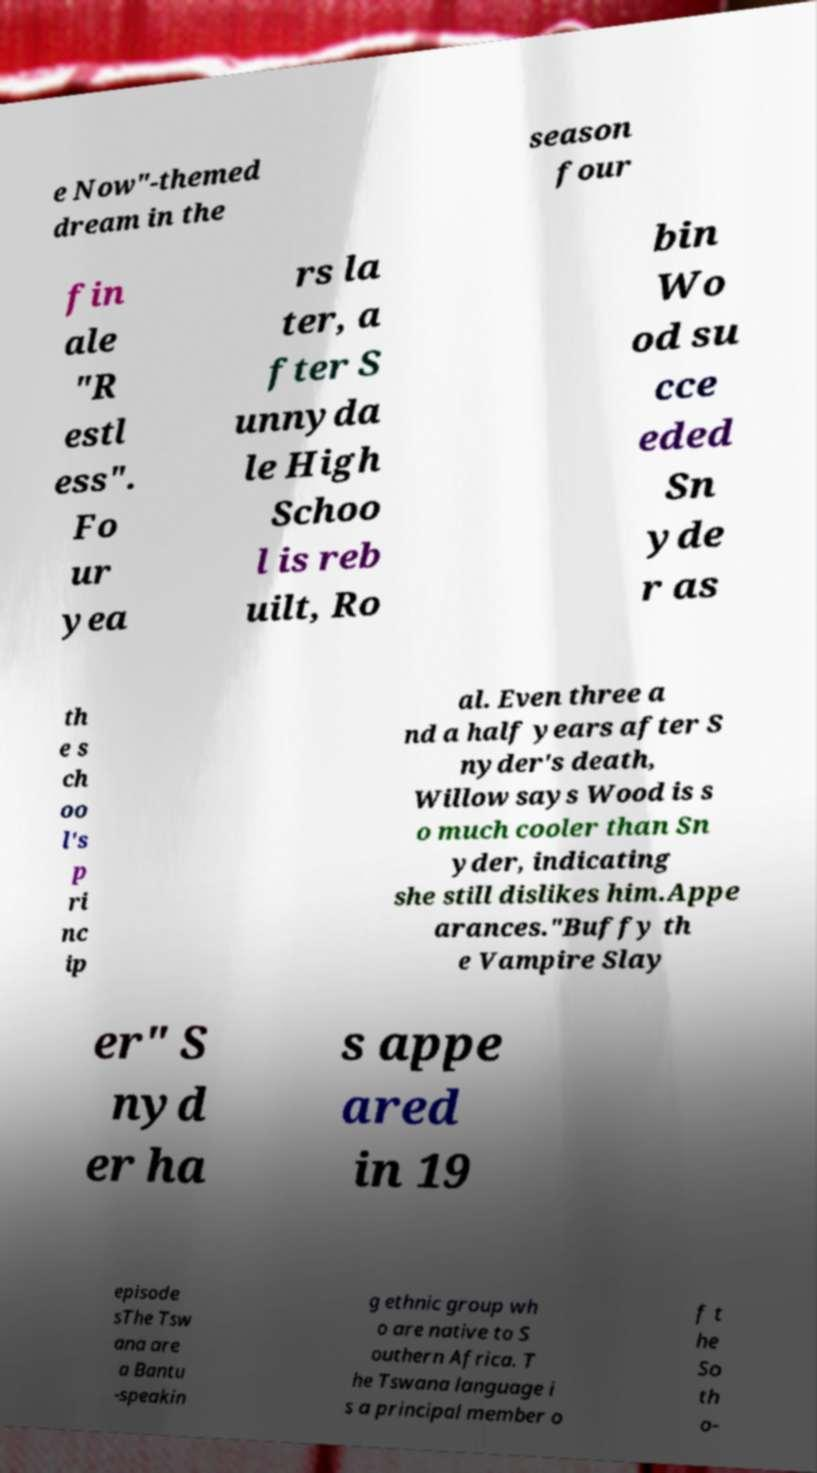I need the written content from this picture converted into text. Can you do that? e Now"-themed dream in the season four fin ale "R estl ess". Fo ur yea rs la ter, a fter S unnyda le High Schoo l is reb uilt, Ro bin Wo od su cce eded Sn yde r as th e s ch oo l's p ri nc ip al. Even three a nd a half years after S nyder's death, Willow says Wood is s o much cooler than Sn yder, indicating she still dislikes him.Appe arances."Buffy th e Vampire Slay er" S nyd er ha s appe ared in 19 episode sThe Tsw ana are a Bantu -speakin g ethnic group wh o are native to S outhern Africa. T he Tswana language i s a principal member o f t he So th o- 